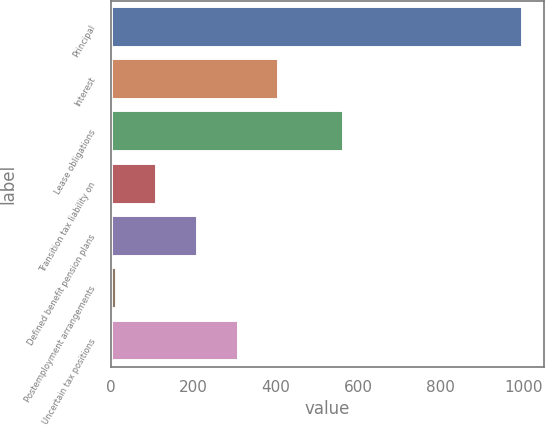<chart> <loc_0><loc_0><loc_500><loc_500><bar_chart><fcel>Principal<fcel>Interest<fcel>Lease obligations<fcel>Transition tax liability on<fcel>Defined benefit pension plans<fcel>Postemployment arrangements<fcel>Uncertain tax positions<nl><fcel>1000<fcel>408.88<fcel>565.6<fcel>113.32<fcel>211.84<fcel>14.8<fcel>310.36<nl></chart> 